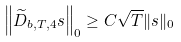<formula> <loc_0><loc_0><loc_500><loc_500>\left \| \widetilde { D } _ { b , T , 4 } s \right \| _ { 0 } \geq C \sqrt { T } { \| s \| _ { 0 } }</formula> 